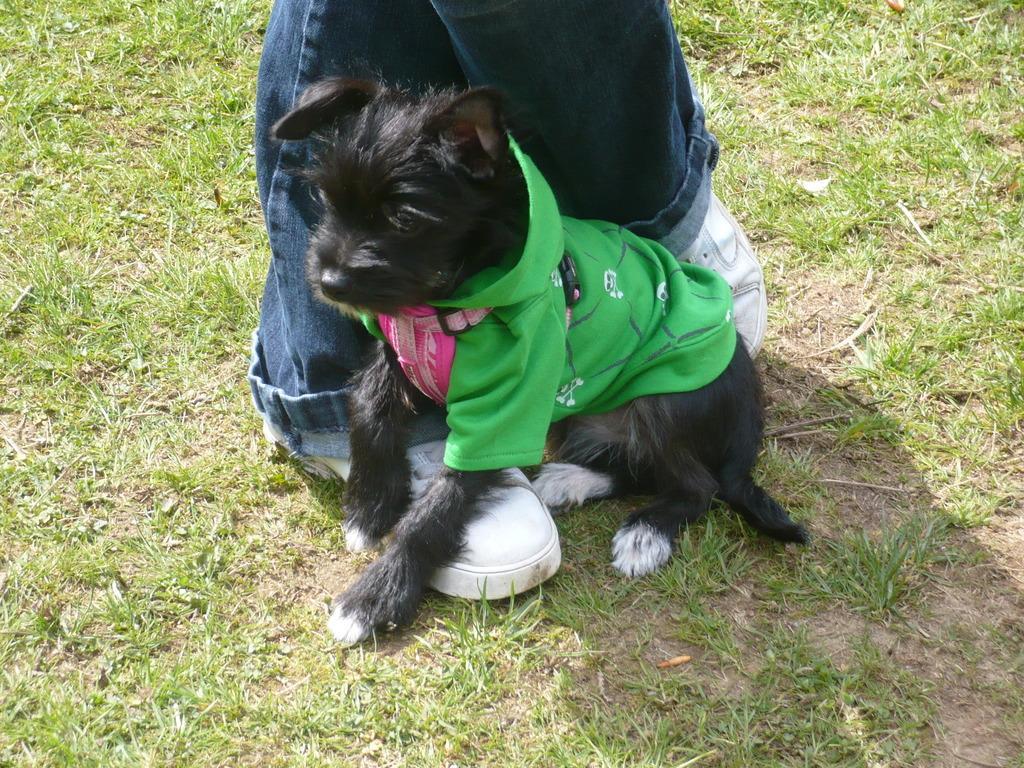In one or two sentences, can you explain what this image depicts? In this image we can see the legs of a person. There is a grassy land in the image. We can see a dog is wearing a cloth in the image. 